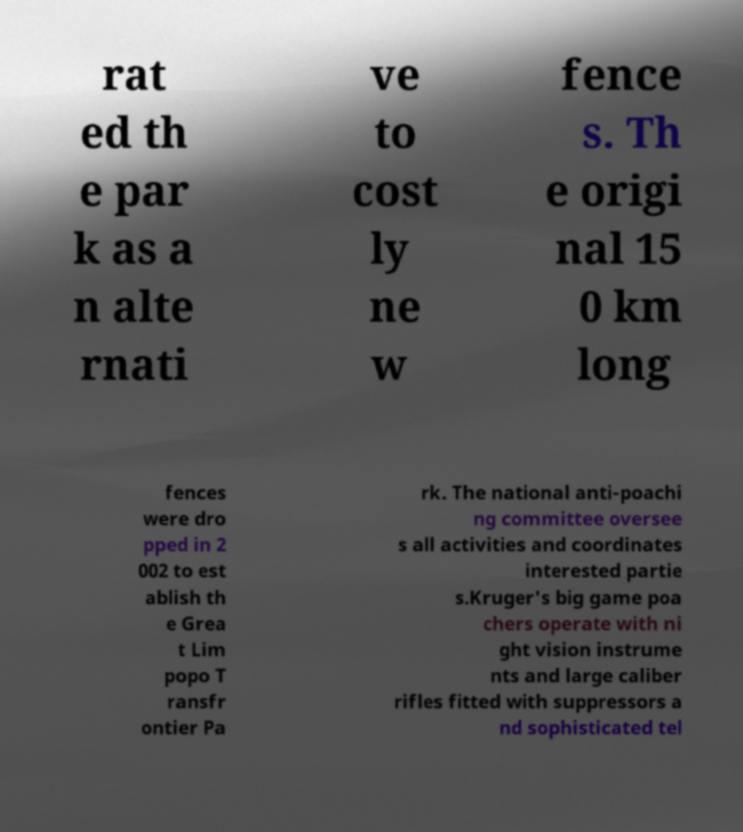What messages or text are displayed in this image? I need them in a readable, typed format. rat ed th e par k as a n alte rnati ve to cost ly ne w fence s. Th e origi nal 15 0 km long fences were dro pped in 2 002 to est ablish th e Grea t Lim popo T ransfr ontier Pa rk. The national anti-poachi ng committee oversee s all activities and coordinates interested partie s.Kruger's big game poa chers operate with ni ght vision instrume nts and large caliber rifles fitted with suppressors a nd sophisticated tel 